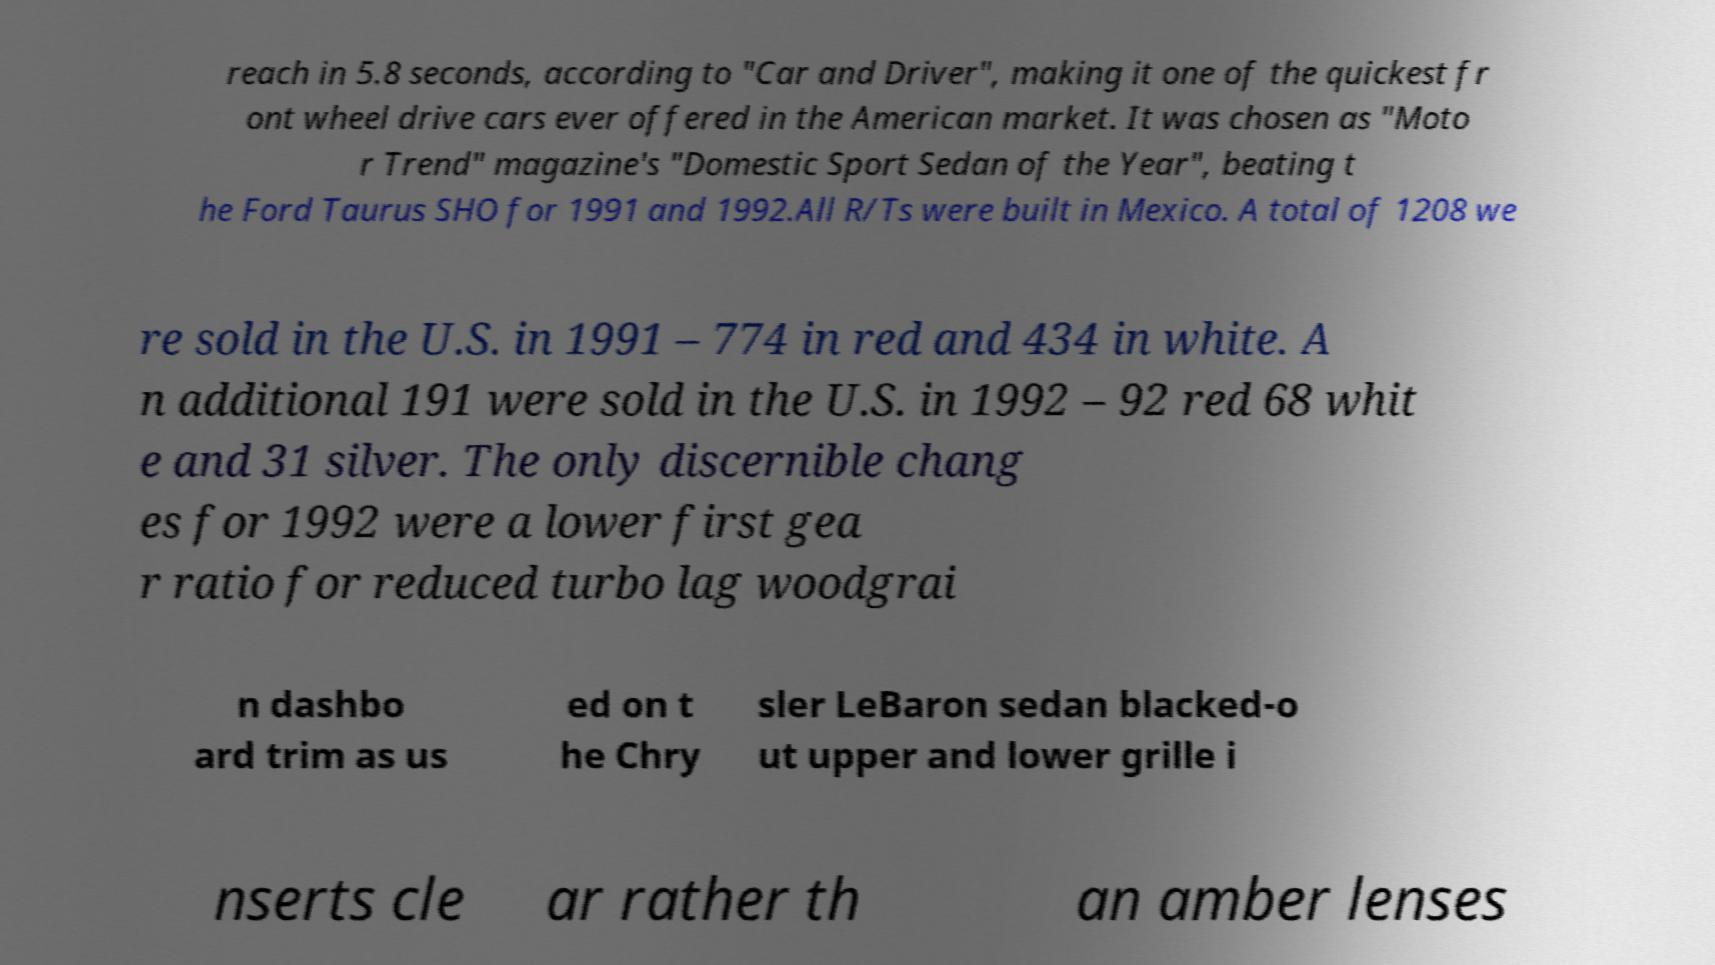I need the written content from this picture converted into text. Can you do that? reach in 5.8 seconds, according to "Car and Driver", making it one of the quickest fr ont wheel drive cars ever offered in the American market. It was chosen as "Moto r Trend" magazine's "Domestic Sport Sedan of the Year", beating t he Ford Taurus SHO for 1991 and 1992.All R/Ts were built in Mexico. A total of 1208 we re sold in the U.S. in 1991 – 774 in red and 434 in white. A n additional 191 were sold in the U.S. in 1992 – 92 red 68 whit e and 31 silver. The only discernible chang es for 1992 were a lower first gea r ratio for reduced turbo lag woodgrai n dashbo ard trim as us ed on t he Chry sler LeBaron sedan blacked-o ut upper and lower grille i nserts cle ar rather th an amber lenses 